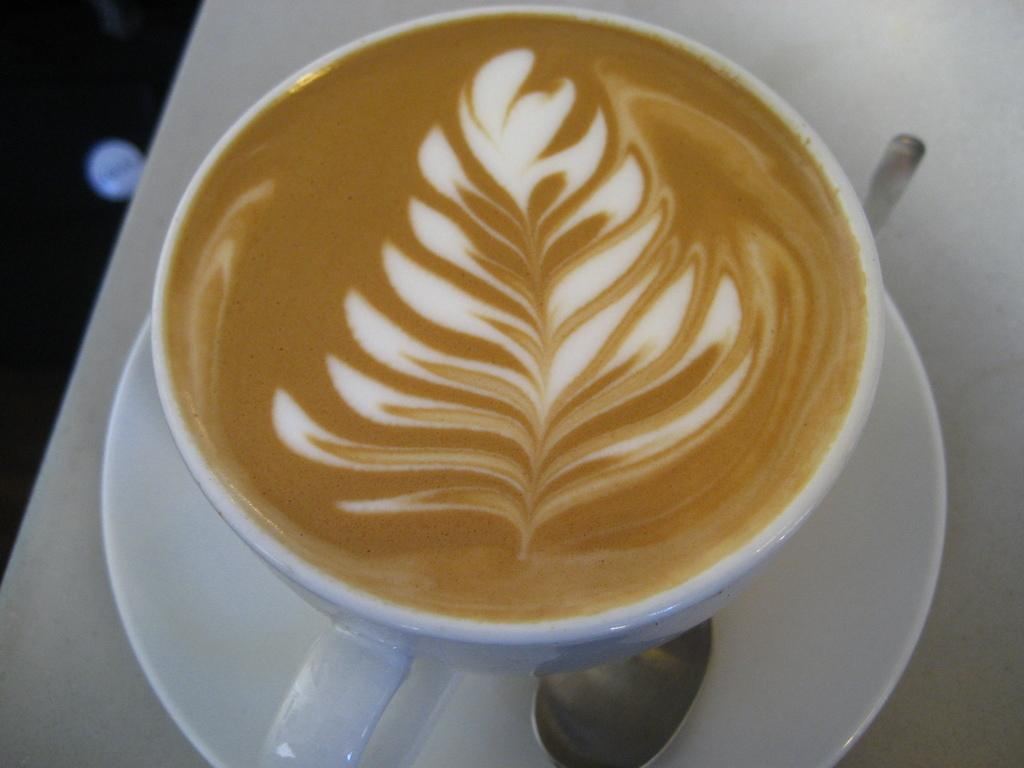What is in the cup that is visible in the image? There is a cup containing coffee in the image. How is the cup supported in the image? The cup is placed on a saucer. What utensil is present in the image? A spoon is present in the image. Where are the cup, saucer, and spoon located in the image? The cup, saucer, and spoon are placed on a table. What degree does the fly have in the image? There is no fly present in the image, so it is not possible to determine its degree. 